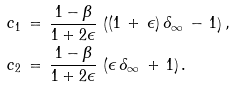<formula> <loc_0><loc_0><loc_500><loc_500>c _ { 1 } \, & = \, \frac { 1 - \beta } { 1 + 2 \epsilon } \, \left ( ( 1 \, + \, \epsilon ) \, \delta _ { \infty } \, - \, 1 \right ) , \\ c _ { 2 } \, & = \, \frac { 1 - \beta } { 1 + 2 \epsilon } \, \left ( \epsilon \, \delta _ { \infty } \, + \, 1 \right ) .</formula> 